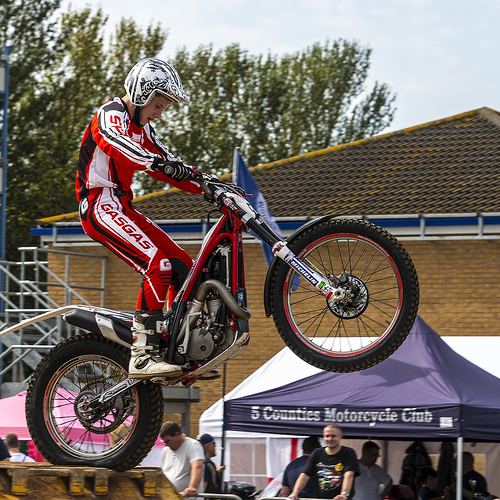<image>
Is there a man behind the bike? No. The man is not behind the bike. From this viewpoint, the man appears to be positioned elsewhere in the scene. Where is the rider in relation to the bike? Is it in front of the bike? No. The rider is not in front of the bike. The spatial positioning shows a different relationship between these objects. 